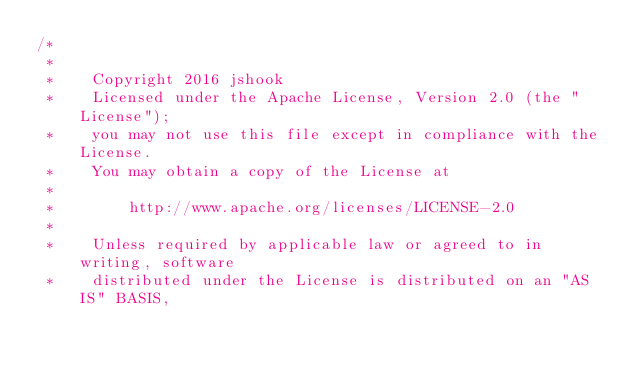<code> <loc_0><loc_0><loc_500><loc_500><_Java_>/*
 *
 *    Copyright 2016 jshook
 *    Licensed under the Apache License, Version 2.0 (the "License");
 *    you may not use this file except in compliance with the License.
 *    You may obtain a copy of the License at
 *
 *        http://www.apache.org/licenses/LICENSE-2.0
 *
 *    Unless required by applicable law or agreed to in writing, software
 *    distributed under the License is distributed on an "AS IS" BASIS,</code> 